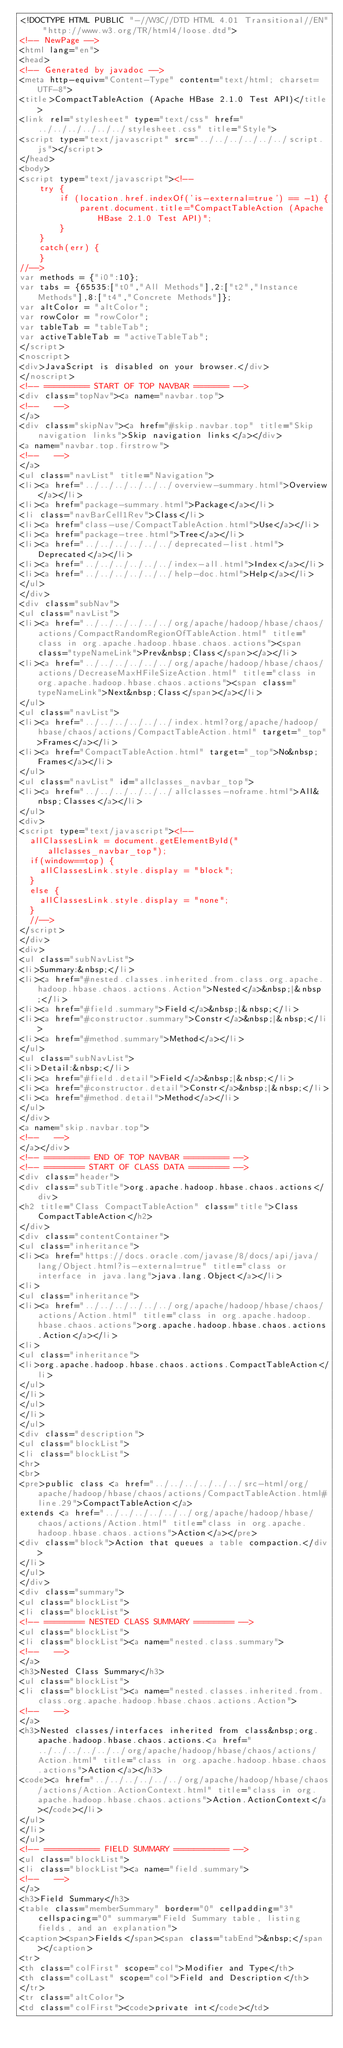<code> <loc_0><loc_0><loc_500><loc_500><_HTML_><!DOCTYPE HTML PUBLIC "-//W3C//DTD HTML 4.01 Transitional//EN" "http://www.w3.org/TR/html4/loose.dtd">
<!-- NewPage -->
<html lang="en">
<head>
<!-- Generated by javadoc -->
<meta http-equiv="Content-Type" content="text/html; charset=UTF-8">
<title>CompactTableAction (Apache HBase 2.1.0 Test API)</title>
<link rel="stylesheet" type="text/css" href="../../../../../../stylesheet.css" title="Style">
<script type="text/javascript" src="../../../../../../script.js"></script>
</head>
<body>
<script type="text/javascript"><!--
    try {
        if (location.href.indexOf('is-external=true') == -1) {
            parent.document.title="CompactTableAction (Apache HBase 2.1.0 Test API)";
        }
    }
    catch(err) {
    }
//-->
var methods = {"i0":10};
var tabs = {65535:["t0","All Methods"],2:["t2","Instance Methods"],8:["t4","Concrete Methods"]};
var altColor = "altColor";
var rowColor = "rowColor";
var tableTab = "tableTab";
var activeTableTab = "activeTableTab";
</script>
<noscript>
<div>JavaScript is disabled on your browser.</div>
</noscript>
<!-- ========= START OF TOP NAVBAR ======= -->
<div class="topNav"><a name="navbar.top">
<!--   -->
</a>
<div class="skipNav"><a href="#skip.navbar.top" title="Skip navigation links">Skip navigation links</a></div>
<a name="navbar.top.firstrow">
<!--   -->
</a>
<ul class="navList" title="Navigation">
<li><a href="../../../../../../overview-summary.html">Overview</a></li>
<li><a href="package-summary.html">Package</a></li>
<li class="navBarCell1Rev">Class</li>
<li><a href="class-use/CompactTableAction.html">Use</a></li>
<li><a href="package-tree.html">Tree</a></li>
<li><a href="../../../../../../deprecated-list.html">Deprecated</a></li>
<li><a href="../../../../../../index-all.html">Index</a></li>
<li><a href="../../../../../../help-doc.html">Help</a></li>
</ul>
</div>
<div class="subNav">
<ul class="navList">
<li><a href="../../../../../../org/apache/hadoop/hbase/chaos/actions/CompactRandomRegionOfTableAction.html" title="class in org.apache.hadoop.hbase.chaos.actions"><span class="typeNameLink">Prev&nbsp;Class</span></a></li>
<li><a href="../../../../../../org/apache/hadoop/hbase/chaos/actions/DecreaseMaxHFileSizeAction.html" title="class in org.apache.hadoop.hbase.chaos.actions"><span class="typeNameLink">Next&nbsp;Class</span></a></li>
</ul>
<ul class="navList">
<li><a href="../../../../../../index.html?org/apache/hadoop/hbase/chaos/actions/CompactTableAction.html" target="_top">Frames</a></li>
<li><a href="CompactTableAction.html" target="_top">No&nbsp;Frames</a></li>
</ul>
<ul class="navList" id="allclasses_navbar_top">
<li><a href="../../../../../../allclasses-noframe.html">All&nbsp;Classes</a></li>
</ul>
<div>
<script type="text/javascript"><!--
  allClassesLink = document.getElementById("allclasses_navbar_top");
  if(window==top) {
    allClassesLink.style.display = "block";
  }
  else {
    allClassesLink.style.display = "none";
  }
  //-->
</script>
</div>
<div>
<ul class="subNavList">
<li>Summary:&nbsp;</li>
<li><a href="#nested.classes.inherited.from.class.org.apache.hadoop.hbase.chaos.actions.Action">Nested</a>&nbsp;|&nbsp;</li>
<li><a href="#field.summary">Field</a>&nbsp;|&nbsp;</li>
<li><a href="#constructor.summary">Constr</a>&nbsp;|&nbsp;</li>
<li><a href="#method.summary">Method</a></li>
</ul>
<ul class="subNavList">
<li>Detail:&nbsp;</li>
<li><a href="#field.detail">Field</a>&nbsp;|&nbsp;</li>
<li><a href="#constructor.detail">Constr</a>&nbsp;|&nbsp;</li>
<li><a href="#method.detail">Method</a></li>
</ul>
</div>
<a name="skip.navbar.top">
<!--   -->
</a></div>
<!-- ========= END OF TOP NAVBAR ========= -->
<!-- ======== START OF CLASS DATA ======== -->
<div class="header">
<div class="subTitle">org.apache.hadoop.hbase.chaos.actions</div>
<h2 title="Class CompactTableAction" class="title">Class CompactTableAction</h2>
</div>
<div class="contentContainer">
<ul class="inheritance">
<li><a href="https://docs.oracle.com/javase/8/docs/api/java/lang/Object.html?is-external=true" title="class or interface in java.lang">java.lang.Object</a></li>
<li>
<ul class="inheritance">
<li><a href="../../../../../../org/apache/hadoop/hbase/chaos/actions/Action.html" title="class in org.apache.hadoop.hbase.chaos.actions">org.apache.hadoop.hbase.chaos.actions.Action</a></li>
<li>
<ul class="inheritance">
<li>org.apache.hadoop.hbase.chaos.actions.CompactTableAction</li>
</ul>
</li>
</ul>
</li>
</ul>
<div class="description">
<ul class="blockList">
<li class="blockList">
<hr>
<br>
<pre>public class <a href="../../../../../../src-html/org/apache/hadoop/hbase/chaos/actions/CompactTableAction.html#line.29">CompactTableAction</a>
extends <a href="../../../../../../org/apache/hadoop/hbase/chaos/actions/Action.html" title="class in org.apache.hadoop.hbase.chaos.actions">Action</a></pre>
<div class="block">Action that queues a table compaction.</div>
</li>
</ul>
</div>
<div class="summary">
<ul class="blockList">
<li class="blockList">
<!-- ======== NESTED CLASS SUMMARY ======== -->
<ul class="blockList">
<li class="blockList"><a name="nested.class.summary">
<!--   -->
</a>
<h3>Nested Class Summary</h3>
<ul class="blockList">
<li class="blockList"><a name="nested.classes.inherited.from.class.org.apache.hadoop.hbase.chaos.actions.Action">
<!--   -->
</a>
<h3>Nested classes/interfaces inherited from class&nbsp;org.apache.hadoop.hbase.chaos.actions.<a href="../../../../../../org/apache/hadoop/hbase/chaos/actions/Action.html" title="class in org.apache.hadoop.hbase.chaos.actions">Action</a></h3>
<code><a href="../../../../../../org/apache/hadoop/hbase/chaos/actions/Action.ActionContext.html" title="class in org.apache.hadoop.hbase.chaos.actions">Action.ActionContext</a></code></li>
</ul>
</li>
</ul>
<!-- =========== FIELD SUMMARY =========== -->
<ul class="blockList">
<li class="blockList"><a name="field.summary">
<!--   -->
</a>
<h3>Field Summary</h3>
<table class="memberSummary" border="0" cellpadding="3" cellspacing="0" summary="Field Summary table, listing fields, and an explanation">
<caption><span>Fields</span><span class="tabEnd">&nbsp;</span></caption>
<tr>
<th class="colFirst" scope="col">Modifier and Type</th>
<th class="colLast" scope="col">Field and Description</th>
</tr>
<tr class="altColor">
<td class="colFirst"><code>private int</code></td></code> 